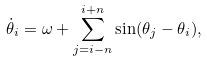<formula> <loc_0><loc_0><loc_500><loc_500>\dot { \theta } _ { i } = \omega + \sum _ { j = i - n } ^ { i + n } \sin ( \theta _ { j } - \theta _ { i } ) ,</formula> 